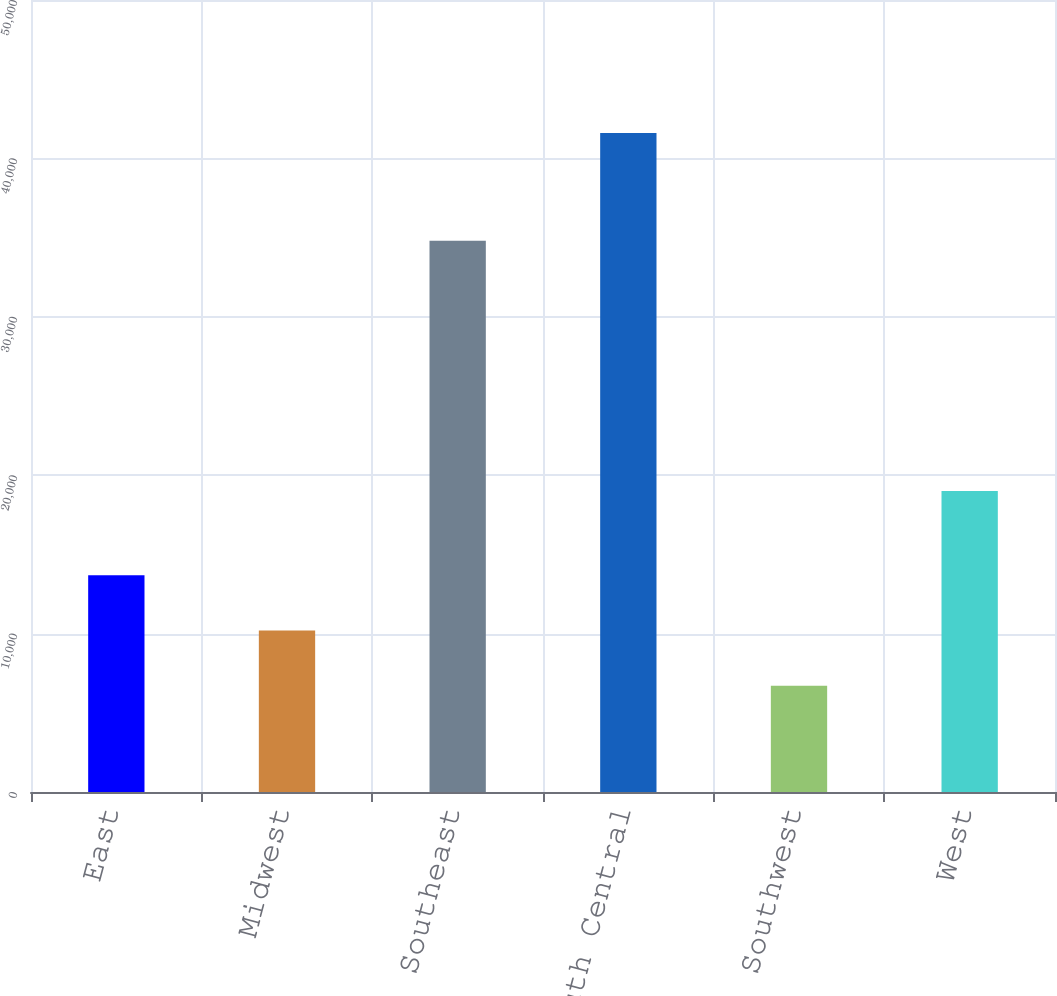Convert chart to OTSL. <chart><loc_0><loc_0><loc_500><loc_500><bar_chart><fcel>East<fcel>Midwest<fcel>Southeast<fcel>South Central<fcel>Southwest<fcel>West<nl><fcel>13680<fcel>10190<fcel>34800<fcel>41600<fcel>6700<fcel>19000<nl></chart> 